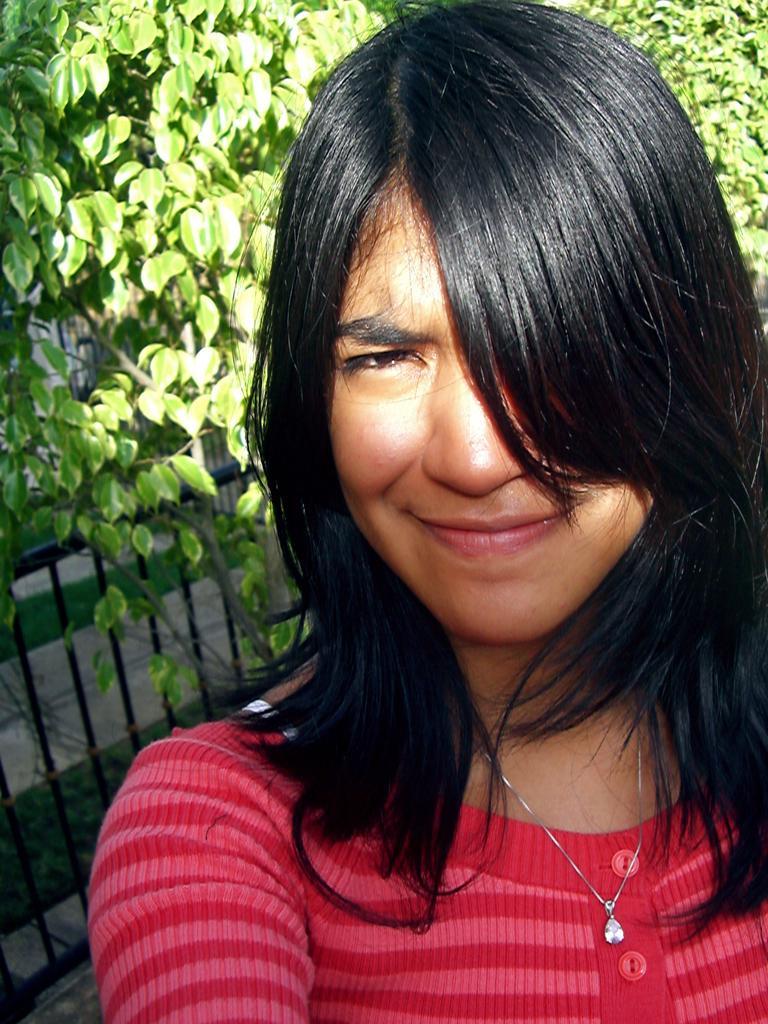How would you summarize this image in a sentence or two? In this image I can see a woman is smiling, she wore red color sweater. On the left side it looks like an iron frame, at the top it is the tree. 